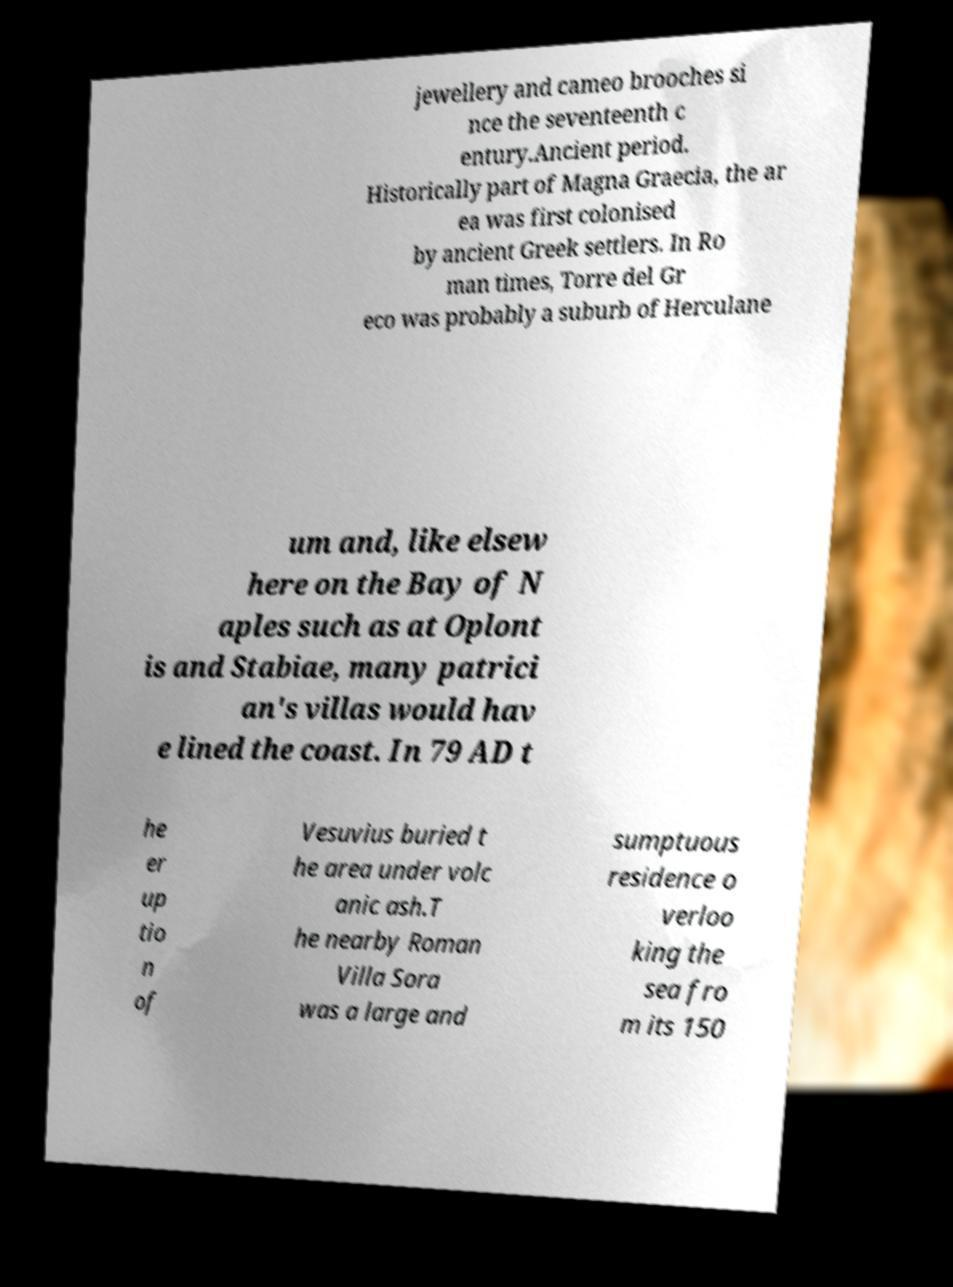Could you extract and type out the text from this image? jewellery and cameo brooches si nce the seventeenth c entury.Ancient period. Historically part of Magna Graecia, the ar ea was first colonised by ancient Greek settlers. In Ro man times, Torre del Gr eco was probably a suburb of Herculane um and, like elsew here on the Bay of N aples such as at Oplont is and Stabiae, many patrici an's villas would hav e lined the coast. In 79 AD t he er up tio n of Vesuvius buried t he area under volc anic ash.T he nearby Roman Villa Sora was a large and sumptuous residence o verloo king the sea fro m its 150 